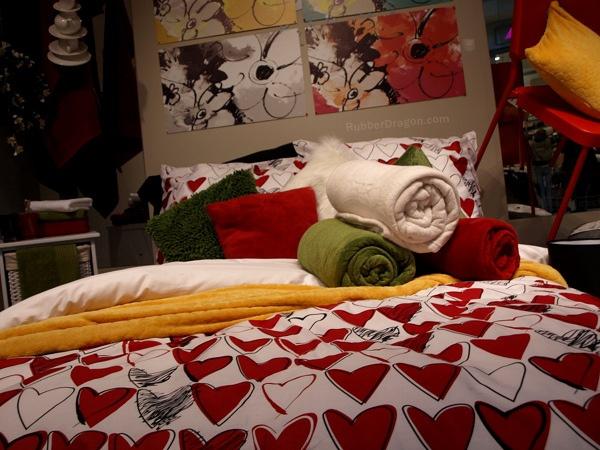Would the average person choose to sit in the chair in its current location?
Give a very brief answer. No. How many blankets are rolled up on the bed?
Be succinct. 3. What is on the bedspread?
Answer briefly. Hearts. 